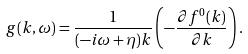<formula> <loc_0><loc_0><loc_500><loc_500>g ( k , \omega ) = \frac { 1 } { ( - i \omega + \eta ) k } \left ( - \frac { \partial f ^ { 0 } ( k ) } { \partial k } \right ) .</formula> 